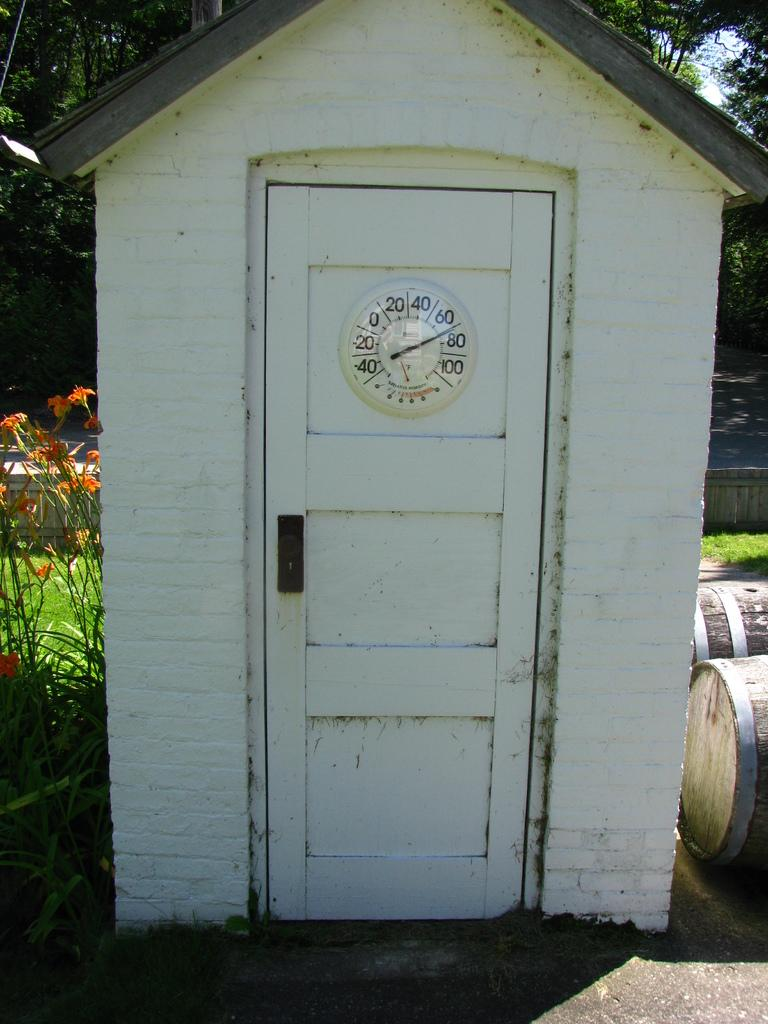<image>
Present a compact description of the photo's key features. A white shed with the thermostat reading 74 degrees. 